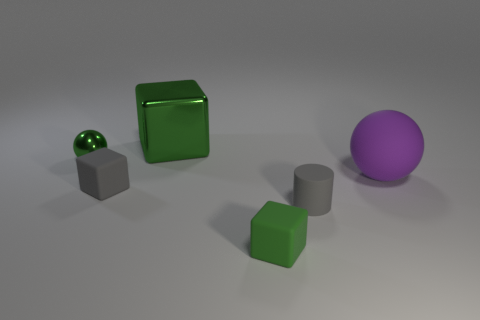Is the green cube hollow or solid? Visually, the green cube has reflective and shiny surfaces, and there are no visible openings that would suggest it's hollow. Therefore, based on appearance alone, it is likely a solid object. However, without additional information such as weight or sound resonance, we cannot conclusively determine its inner structure. 